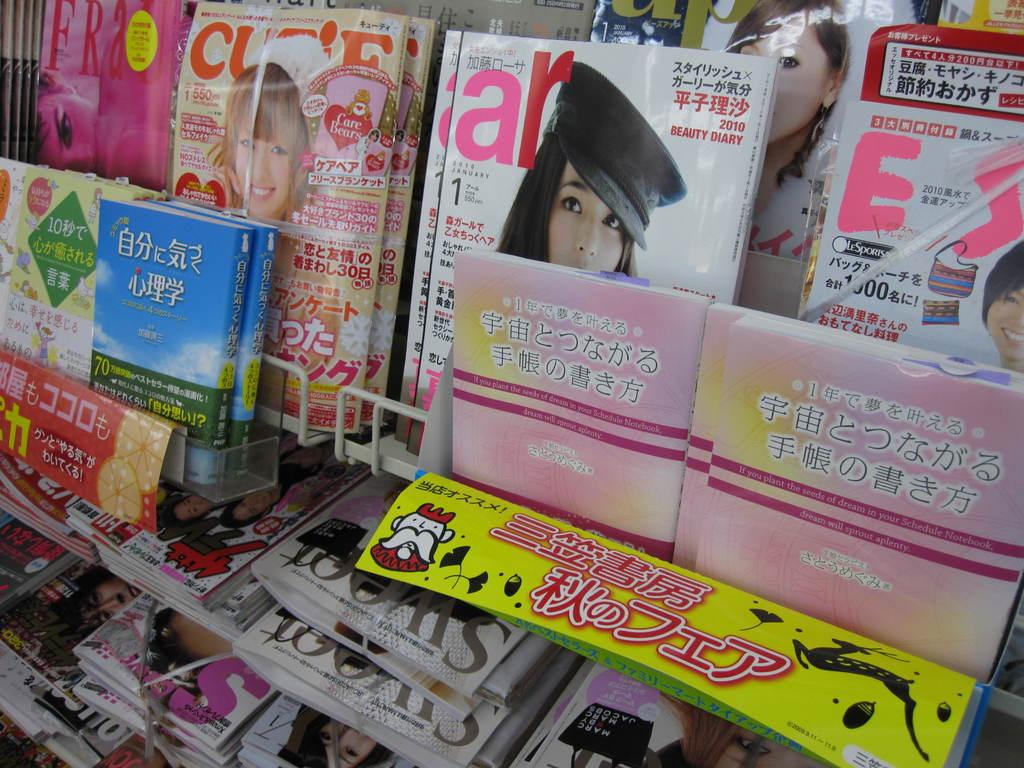What type of reading materials can be seen in the image? There are books and magazines in the image. How are the books and magazines organized in the image? The books and magazines are in racks. Are there any rings visible on the books or magazines in the image? No, there are no rings visible on the books or magazines in the image. Is there any cast present in the image? No, there is no cast present in the image. 